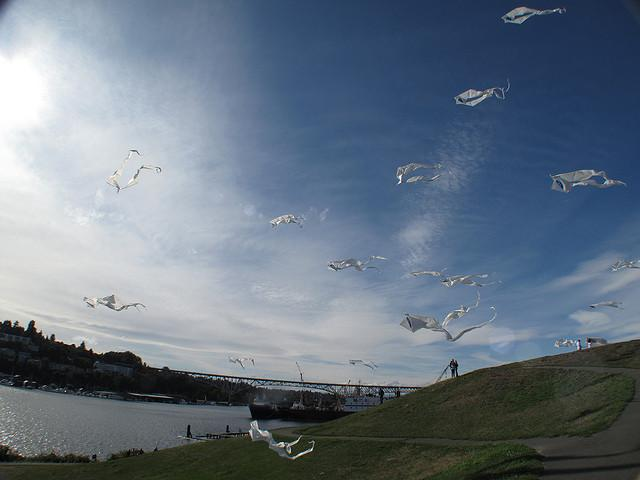How many kind of kite shapes available? Please explain your reasoning. eight. There are eight kites in the sky. 